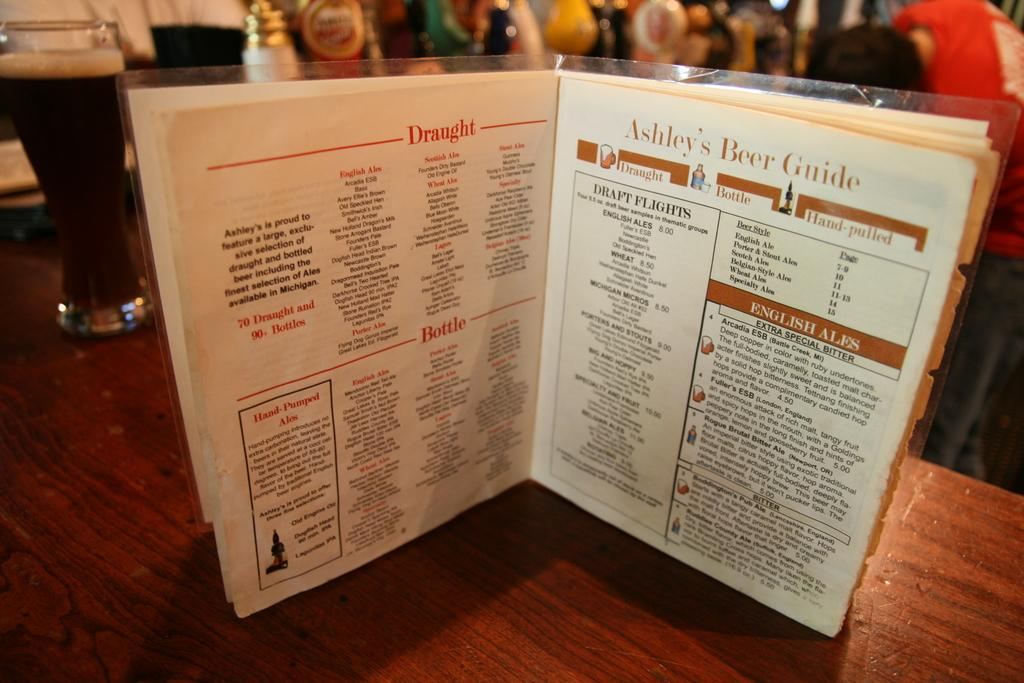<image>
Give a short and clear explanation of the subsequent image. A restaurant menu is open to a page that says Ashley's Beer Guide. 